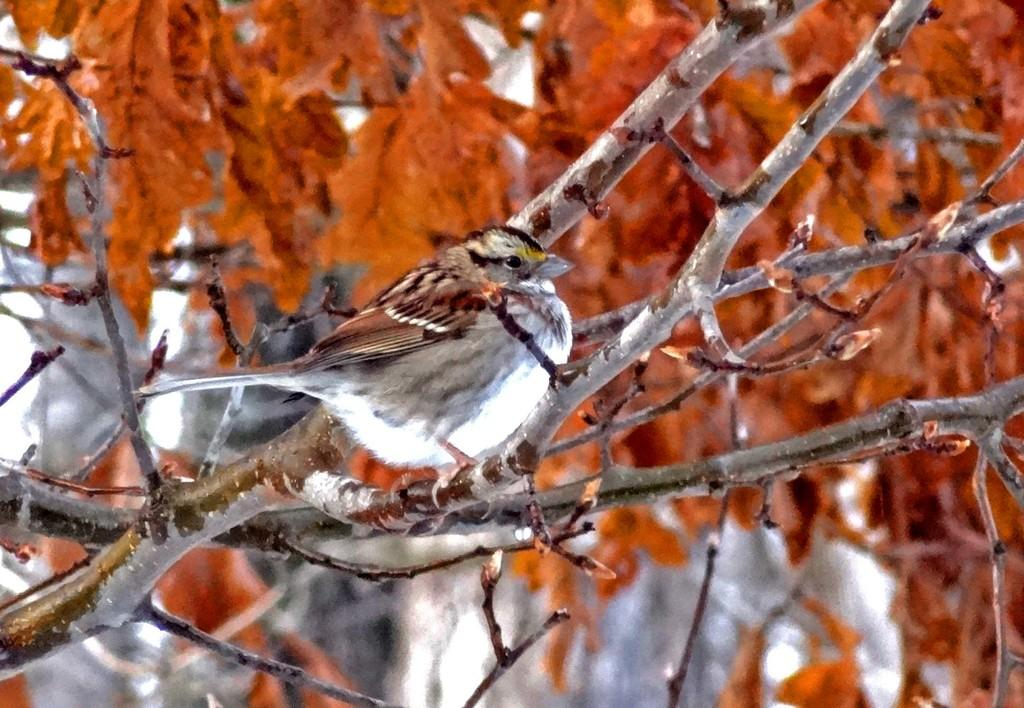What type of animal is present in the image? There is a bird in the image. Can you describe the color of the bird? The bird has white and cream color. What colors can be seen in the background of the image? The background of the image has orange and white colors. Is there a gold locket hanging from the bird's neck in the image? No, there is no gold locket or any other accessory visible on the bird in the image. Can you hear the bird playing a guitar in the image? No, there is no guitar or any sound present in the image; it is a still image of a bird. 